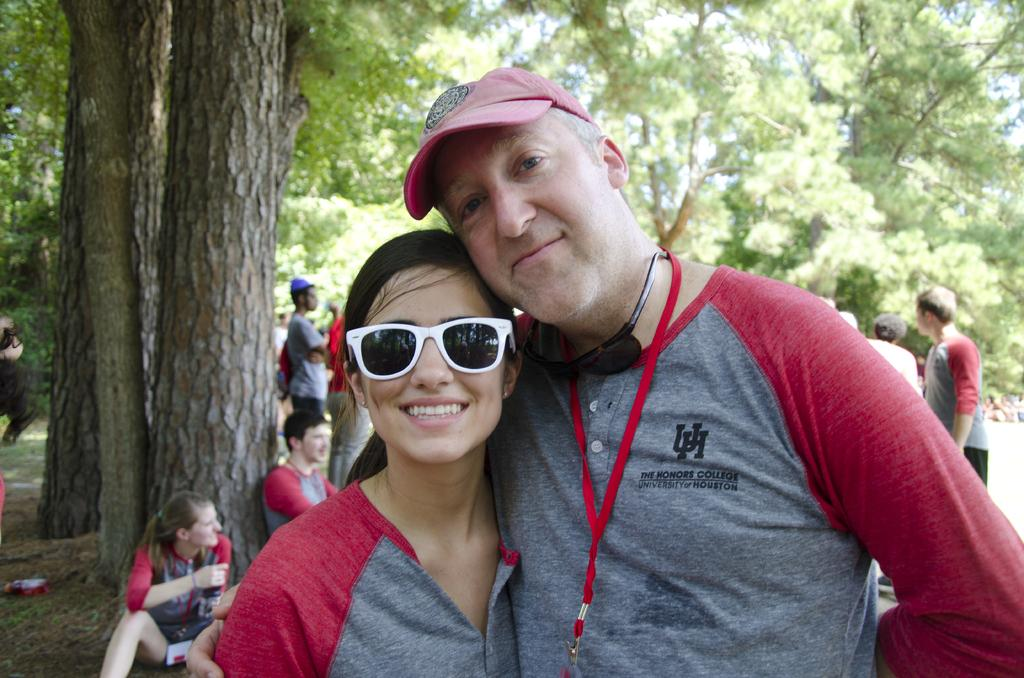What is the clothing item that both the man and woman are wearing in the image? The man and woman are both wearing grey T-shirts in the image. What is the ground surface that the man and woman are standing on? The man and woman are standing on the ground in the image. What is the emotional expression of the man and woman in the image? The man and woman are both smiling in the image. What can be seen in the background of the image? There are more people and trees in the background of the image. What type of drawer is visible in the image? There is no drawer present in the image. What credit card is the man using in the image? There is no credit card or any financial transaction depicted in the image. 